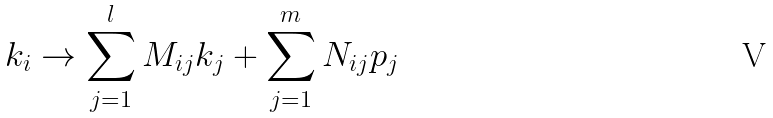Convert formula to latex. <formula><loc_0><loc_0><loc_500><loc_500>k _ { i } & \to \sum _ { j = 1 } ^ { l } M _ { i j } k _ { j } + \sum _ { j = 1 } ^ { m } N _ { i j } p _ { j }</formula> 